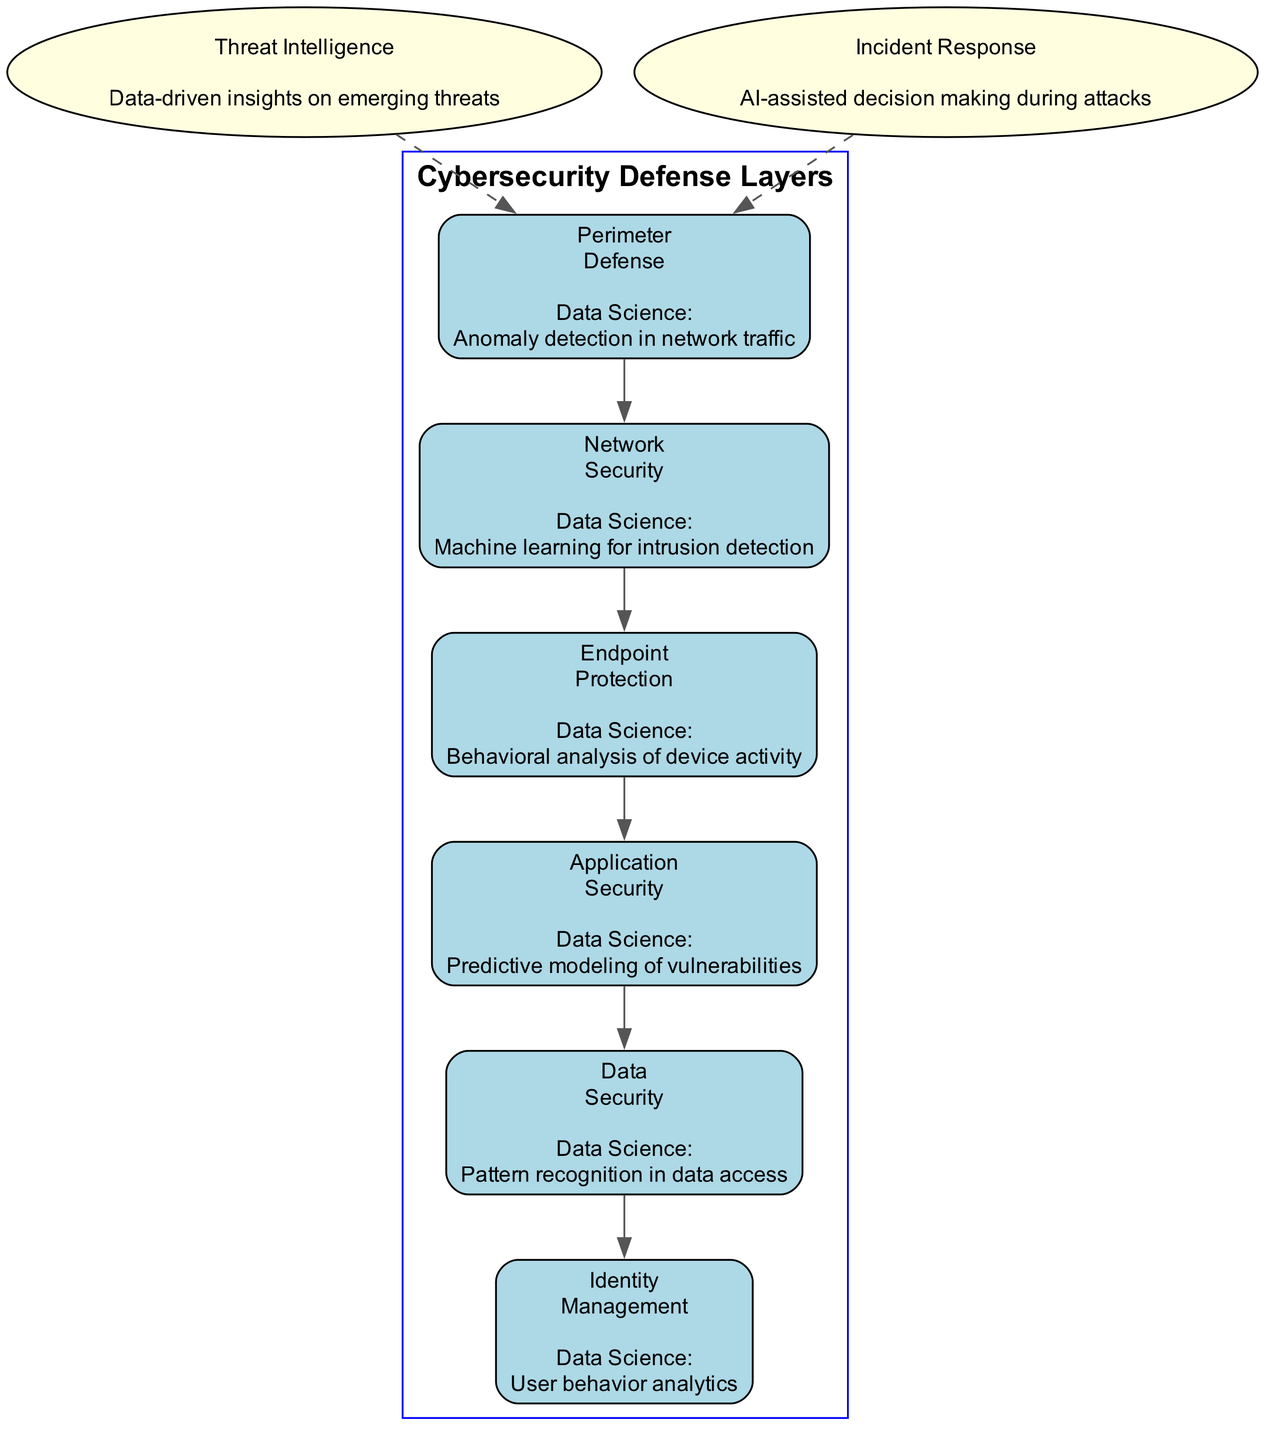What is the data science contribution of the Endpoint Protection layer? The diagram specifies that the data science contribution for Endpoint Protection is "Behavioral analysis of device activity." This is found directly under the Endpoint Protection node in the diagram.
Answer: Behavioral analysis of device activity How many main defense layers are depicted in the diagram? The diagram shows six main defense layers: Perimeter Defense, Network Security, Endpoint Protection, Application Security, Data Security, and Identity Management. These layers are sequentially linked from top to bottom.
Answer: Six What is the primary focus of the Application Security layer? According to the diagram, the Application Security layer's data science contribution is "Predictive modeling of vulnerabilities." Therefore, its primary focus is on identifying potential security weaknesses in applications.
Answer: Predictive modeling of vulnerabilities Which two layers utilize machine learning techniques? The diagram shows that both the Network Security layer (for intrusion detection) and the Perimeter Defense layer (for anomaly detection in network traffic) utilize machine learning techniques. This requires examining both nodes' contributions to gather the answer.
Answer: Network Security and Perimeter Defense What element provides data-driven insights on emerging threats? The diagram indicates that "Threat Intelligence" provides data-driven insights on emerging threats, as described in the additional elements section. This is located separately from the main defense layers but connects to them.
Answer: Threat Intelligence What is the unique contribution of Identity Management in terms of data science? Identity Management contributes through "User behavior analytics," which is specified under its respective node. This contribution relates to overseeing how users interact with the system.
Answer: User behavior analytics How are additional elements connected to the main defense layers? The diagram shows that the additional elements are connected with dashed edges to the Perimeter Defense layer, signifying a different type of relationship compared to the main layer connections. This indicates that they provide supplementary insights rather than being direct components of the core defense.
Answer: Dashed edges Which defense layer involves anomaly detection? Anomaly detection is specifically mentioned as the contribution of the Perimeter Defense layer in the diagram, indicating its role in surveillance over network traffic for unauthorized activities.
Answer: Perimeter Defense 